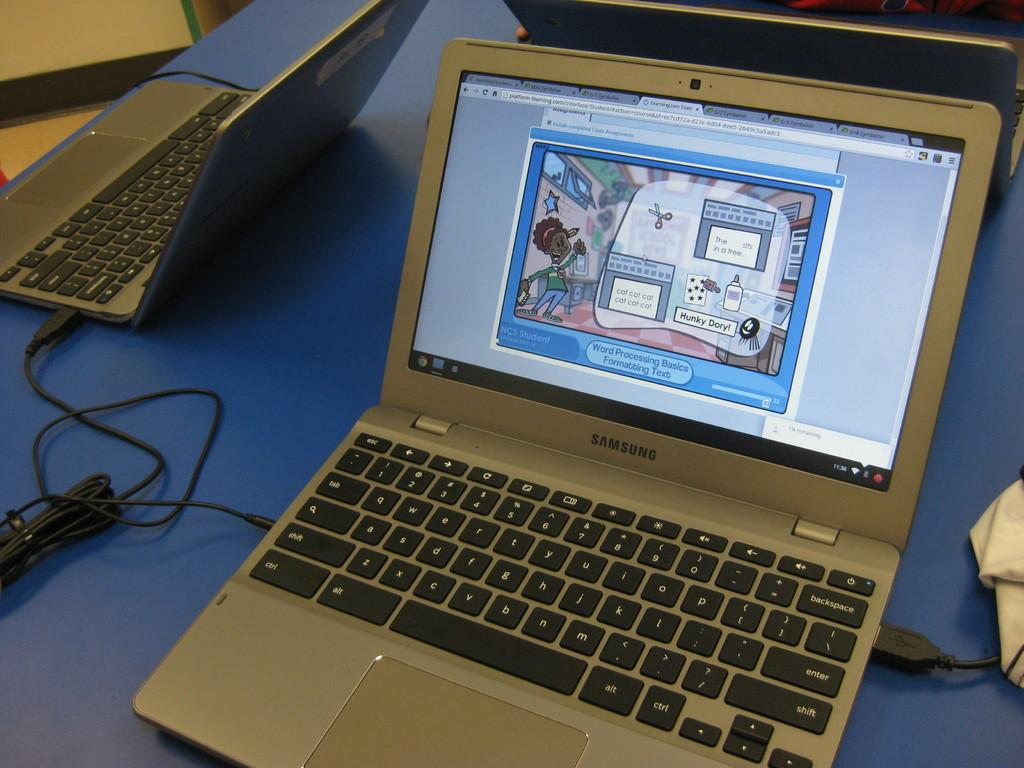<image>
Describe the image concisely. A laptop has a cartoon image on it labeled "Word Processing Basics Formatting Text." 